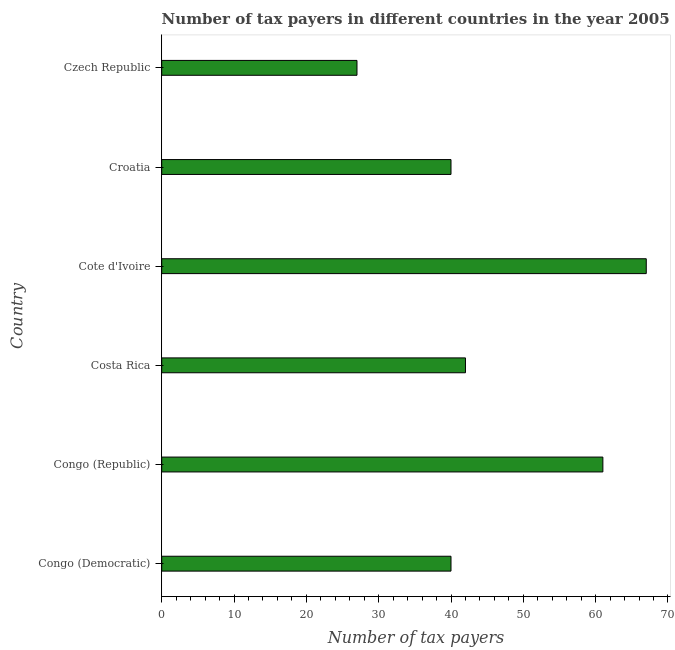Does the graph contain grids?
Keep it short and to the point. No. What is the title of the graph?
Ensure brevity in your answer.  Number of tax payers in different countries in the year 2005. What is the label or title of the X-axis?
Offer a very short reply. Number of tax payers. In which country was the number of tax payers maximum?
Provide a short and direct response. Cote d'Ivoire. In which country was the number of tax payers minimum?
Your answer should be very brief. Czech Republic. What is the sum of the number of tax payers?
Your response must be concise. 277. What is the difference between the number of tax payers in Cote d'Ivoire and Czech Republic?
Your response must be concise. 40. What is the average number of tax payers per country?
Your response must be concise. 46.17. In how many countries, is the number of tax payers greater than 48 ?
Provide a short and direct response. 2. What is the ratio of the number of tax payers in Cote d'Ivoire to that in Czech Republic?
Keep it short and to the point. 2.48. What is the difference between the highest and the second highest number of tax payers?
Provide a succinct answer. 6. What is the difference between the highest and the lowest number of tax payers?
Provide a succinct answer. 40. In how many countries, is the number of tax payers greater than the average number of tax payers taken over all countries?
Offer a terse response. 2. Are all the bars in the graph horizontal?
Your answer should be very brief. Yes. How many countries are there in the graph?
Your answer should be very brief. 6. What is the difference between two consecutive major ticks on the X-axis?
Provide a succinct answer. 10. Are the values on the major ticks of X-axis written in scientific E-notation?
Ensure brevity in your answer.  No. What is the Number of tax payers in Costa Rica?
Keep it short and to the point. 42. What is the Number of tax payers in Cote d'Ivoire?
Keep it short and to the point. 67. What is the Number of tax payers in Croatia?
Offer a terse response. 40. What is the Number of tax payers in Czech Republic?
Offer a terse response. 27. What is the difference between the Number of tax payers in Congo (Democratic) and Cote d'Ivoire?
Give a very brief answer. -27. What is the difference between the Number of tax payers in Congo (Democratic) and Croatia?
Ensure brevity in your answer.  0. What is the difference between the Number of tax payers in Congo (Republic) and Czech Republic?
Your answer should be very brief. 34. What is the difference between the Number of tax payers in Costa Rica and Croatia?
Offer a very short reply. 2. What is the difference between the Number of tax payers in Costa Rica and Czech Republic?
Offer a very short reply. 15. What is the difference between the Number of tax payers in Cote d'Ivoire and Croatia?
Your answer should be compact. 27. What is the difference between the Number of tax payers in Croatia and Czech Republic?
Give a very brief answer. 13. What is the ratio of the Number of tax payers in Congo (Democratic) to that in Congo (Republic)?
Your answer should be compact. 0.66. What is the ratio of the Number of tax payers in Congo (Democratic) to that in Cote d'Ivoire?
Provide a short and direct response. 0.6. What is the ratio of the Number of tax payers in Congo (Democratic) to that in Czech Republic?
Offer a terse response. 1.48. What is the ratio of the Number of tax payers in Congo (Republic) to that in Costa Rica?
Provide a succinct answer. 1.45. What is the ratio of the Number of tax payers in Congo (Republic) to that in Cote d'Ivoire?
Keep it short and to the point. 0.91. What is the ratio of the Number of tax payers in Congo (Republic) to that in Croatia?
Offer a very short reply. 1.52. What is the ratio of the Number of tax payers in Congo (Republic) to that in Czech Republic?
Provide a short and direct response. 2.26. What is the ratio of the Number of tax payers in Costa Rica to that in Cote d'Ivoire?
Provide a short and direct response. 0.63. What is the ratio of the Number of tax payers in Costa Rica to that in Czech Republic?
Keep it short and to the point. 1.56. What is the ratio of the Number of tax payers in Cote d'Ivoire to that in Croatia?
Provide a short and direct response. 1.68. What is the ratio of the Number of tax payers in Cote d'Ivoire to that in Czech Republic?
Provide a short and direct response. 2.48. What is the ratio of the Number of tax payers in Croatia to that in Czech Republic?
Your answer should be very brief. 1.48. 